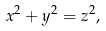Convert formula to latex. <formula><loc_0><loc_0><loc_500><loc_500>x ^ { 2 } + y ^ { 2 } = z ^ { 2 } ,</formula> 